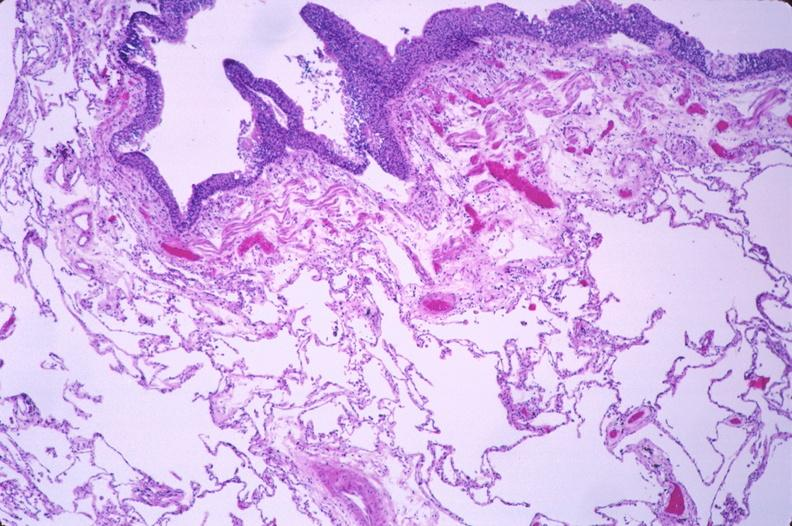does metastatic lung carcinoma show lung, squamous metaplasia of bronchus in a chronic smoker?
Answer the question using a single word or phrase. No 